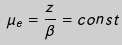<formula> <loc_0><loc_0><loc_500><loc_500>\mu _ { e } = \frac { z } { \beta } = c o n s t</formula> 